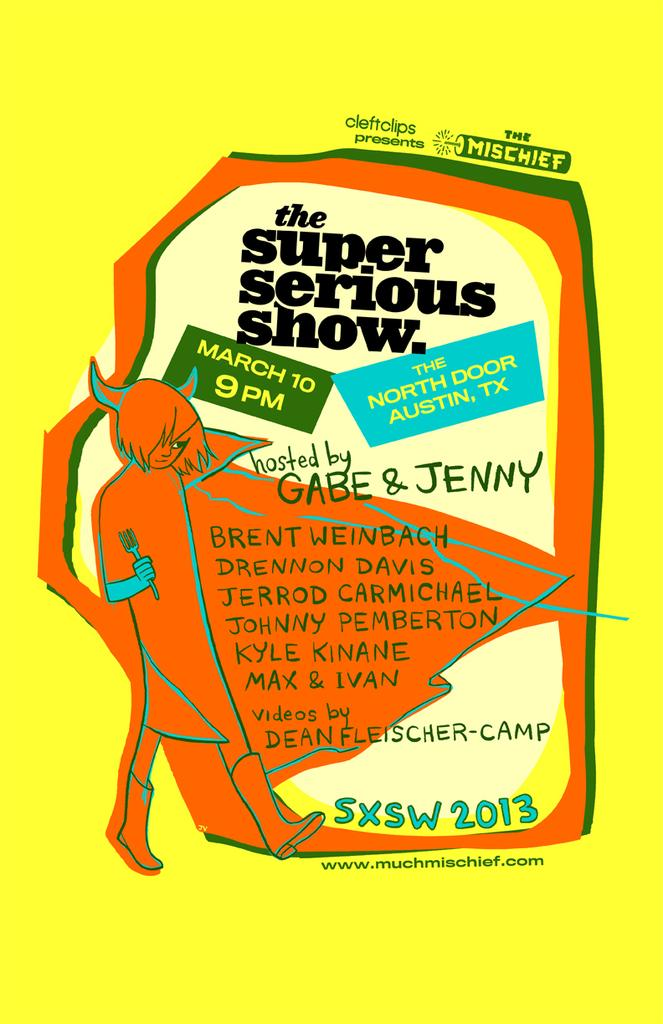<image>
Provide a brief description of the given image. A poster for the super serious show. hosted by Gabe & Jenny 